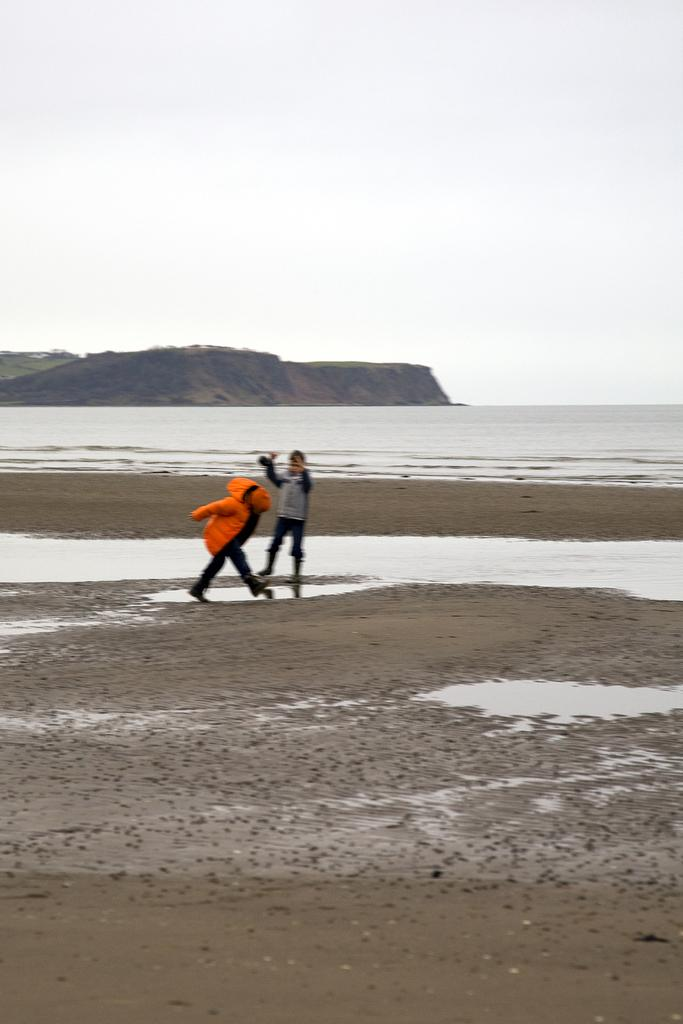How many people are in the image? There are two persons in the middle of the image. What is visible in the background of the image? There is water visible at the back side of the image. What can be seen on the left side of the image? There is a hill on the left side of the image. What is visible at the top of the image? The sky is visible at the top of the image. What color of paint is used to create the jelly texture on the hill in the image? There is no jelly texture or paint present on the hill in the image; it is a natural landscape feature. 